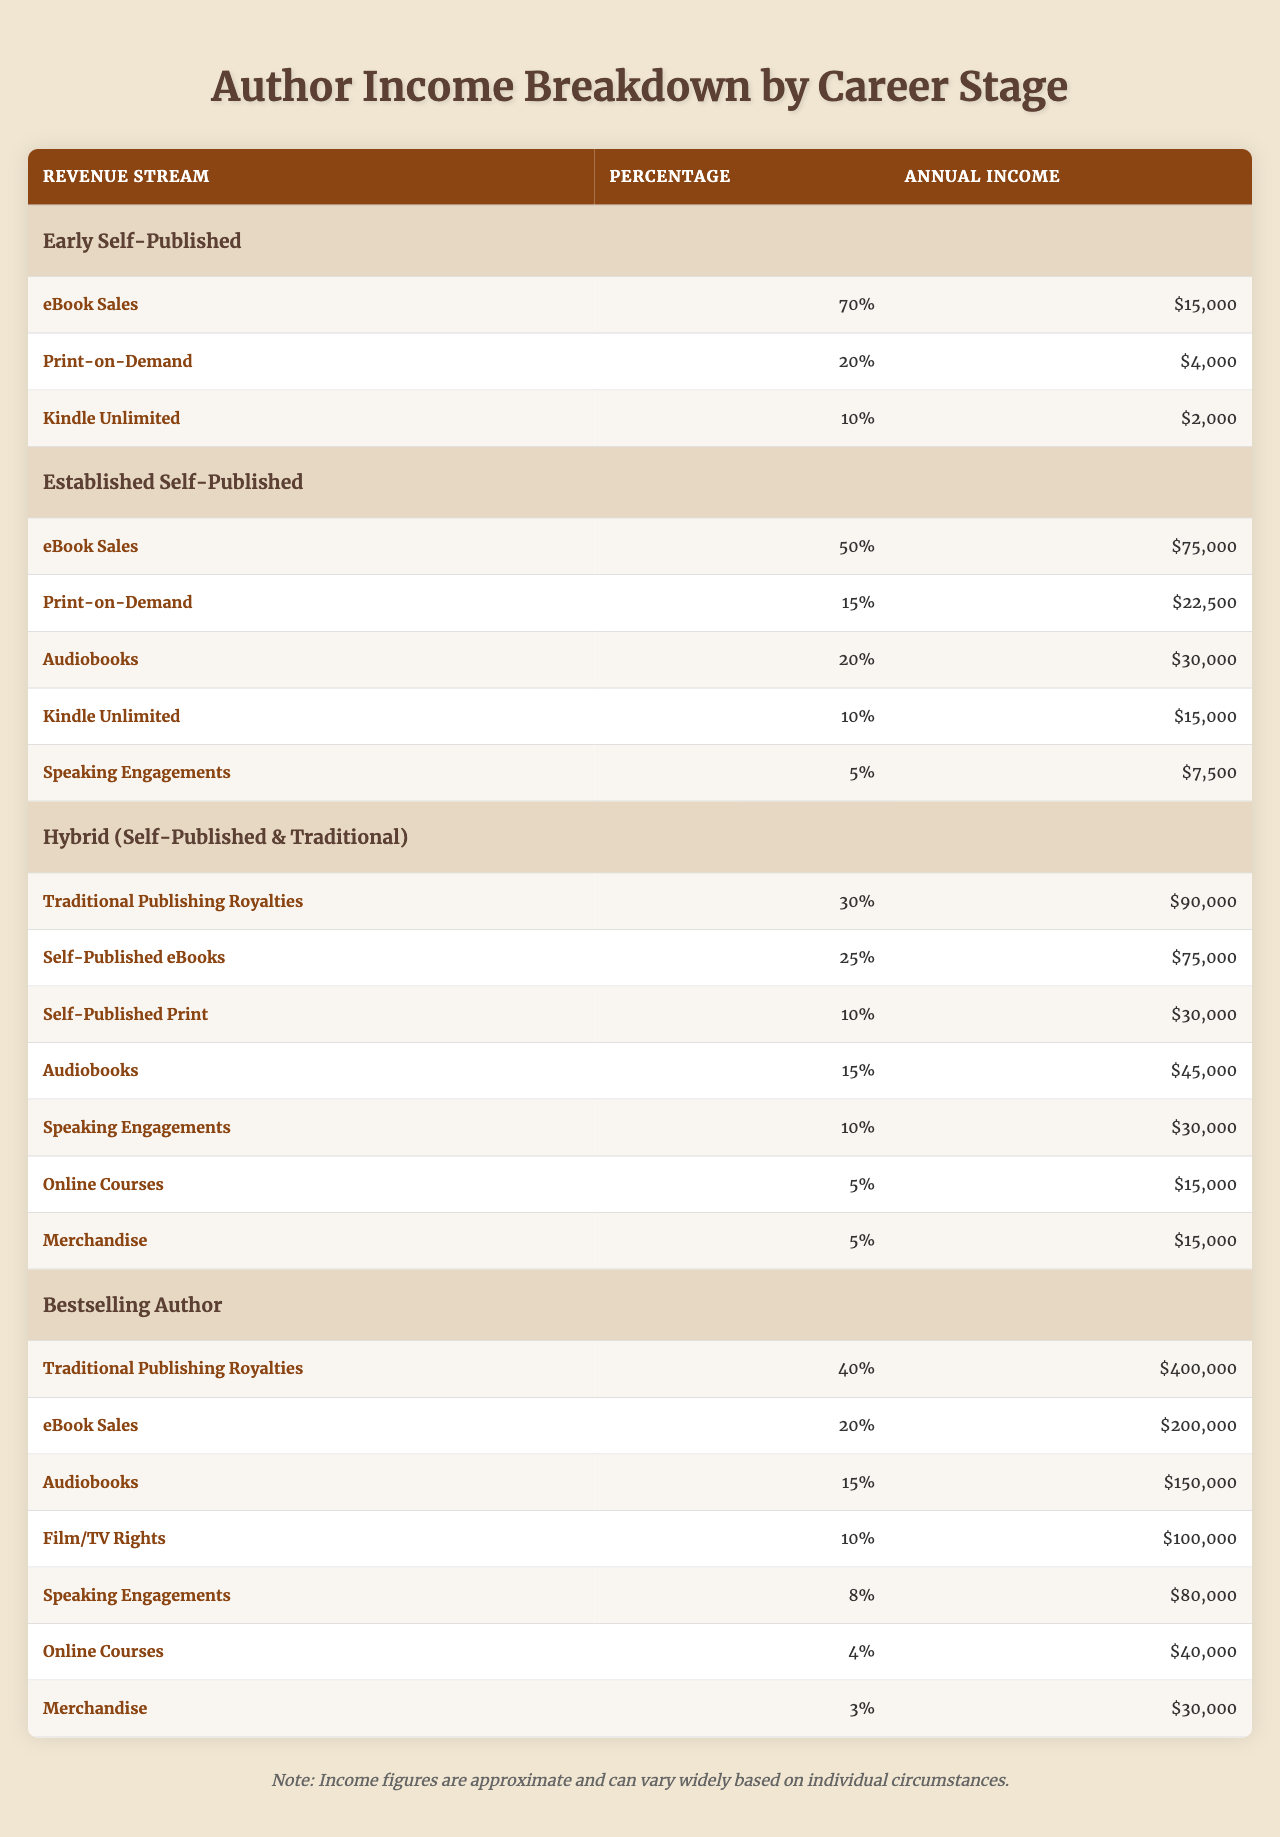What is the annual income from eBook sales for an established self-published author? According to the table, the annual income from eBook sales for the established self-published authors is listed as $75,000.
Answer: $75,000 What percentage of income comes from print-on-demand sales for early self-published authors? The table shows that early self-published authors earn 20% of their income from print-on-demand sales.
Answer: 20% For a bestselling author, what is the total annual income from audiobooks? The table indicates that bestselling authors earn $150,000 from audiobooks, which is the only revenue stream considered in this question.
Answer: $150,000 Is the annual income from speaking engagements higher for hybrid authors than for established self-published authors? The table shows hybrid authors earn $30,000 from speaking engagements, while established self-published authors earn $7,500; therefore, yes, hybrid authors earn more.
Answer: Yes What is the total percentage of income derived from all revenue streams for a bestselling author? To find the total percentage, sum the percentages of each revenue stream for the bestselling author: 40 + 20 + 15 + 10 + 8 + 4 + 3 = 100%.
Answer: 100% How much more does a bestselling author earn from traditional publishing royalties compared to an established self-published author? The bestselling author earns $400,000 from traditional publishing royalties, while the established self-published author earns $75,000. The difference is $400,000 - $75,000 = $325,000.
Answer: $325,000 What is the average annual income from revenue streams for hybrid authors? First, add up all annual incomes from the hybrid author's streams: $90,000 + $75,000 + $30,000 + $45,000 + $30,000 + $15,000 + $15,000 = $300,000. Then, divide by the number of revenue streams (7) to get the average: $300,000 / 7 = $42,857.14, which can be rounded to $42,857.
Answer: $42,857 Is the income from Kindle Unlimited for established self-published authors greater than that of early self-published authors? The table shows that established self-published authors earn $15,000 from Kindle Unlimited, while early self-published authors earn $2,000. Therefore, the income is indeed greater for established authors.
Answer: Yes What is the combined annual income from online courses and merchandise for bestselling authors? The table provides $40,000 for online courses and $30,000 for merchandise. Therefore, the combined annual income is $40,000 + $30,000 = $70,000.
Answer: $70,000 What revenue stream contributes the least percentage of income for established self-published authors? From the table, speaking engagements contribute the least percentage, which is 5%.
Answer: 5% 